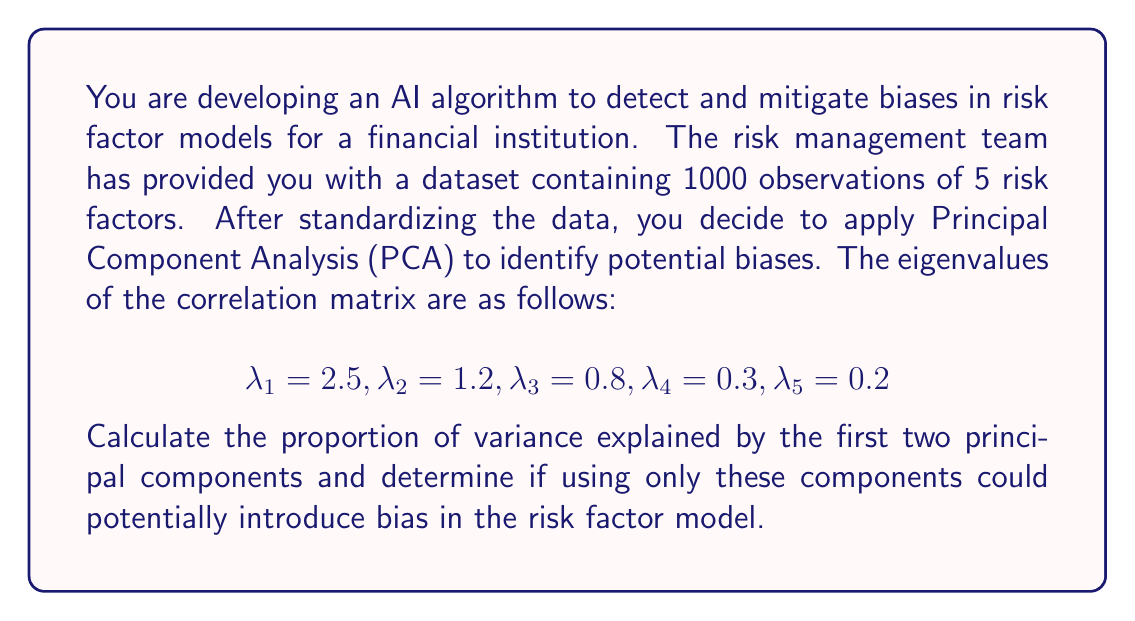Provide a solution to this math problem. To solve this problem, we'll follow these steps:

1) First, let's recall that in PCA, the proportion of variance explained by each principal component is given by its eigenvalue divided by the sum of all eigenvalues.

2) Calculate the total variance:
   $$\text{Total Variance} = \sum_{i=1}^5 \lambda_i = 2.5 + 1.2 + 0.8 + 0.3 + 0.2 = 5$$

   This is expected, as we're working with the correlation matrix of standardized data, where the total variance equals the number of variables.

3) Calculate the proportion of variance explained by the first principal component:
   $$\text{Proportion}_1 = \frac{\lambda_1}{\text{Total Variance}} = \frac{2.5}{5} = 0.5 = 50\%$$

4) Calculate the proportion of variance explained by the second principal component:
   $$\text{Proportion}_2 = \frac{\lambda_2}{\text{Total Variance}} = \frac{1.2}{5} = 0.24 = 24\%$$

5) Sum the proportions for the first two principal components:
   $$\text{Total Proportion} = 0.5 + 0.24 = 0.74 = 74\%$$

6) Interpret the results:
   The first two principal components explain 74% of the total variance in the data. While this is a significant proportion, it means that 26% of the variance is not captured by these components.

7) Consider potential bias:
   Using only the first two principal components could potentially introduce bias in the risk factor model. This is because we're discarding 26% of the information in the original dataset. The discarded information might contain important patterns or relationships that are relevant to certain risk scenarios.

   In the context of bias detection and mitigation, it's crucial to consider whether the discarded components disproportionately affect certain groups or scenarios. For example, if the discarded components are more relevant to rare but high-impact risk events, using only the first two components could lead to underestimating tail risks.

Therefore, while using the first two principal components captures a large proportion of the variance, it's important to carefully consider the potential introduction of bias before deciding to reduce the dimensionality of the risk factor model.
Answer: The proportion of variance explained by the first two principal components is 74%. Using only these components could potentially introduce bias in the risk factor model, as 26% of the variance in the original data is not captured, which may contain important information for certain risk scenarios. 